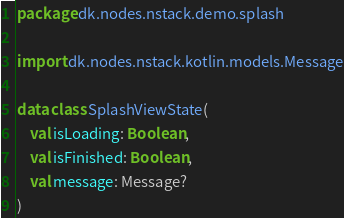Convert code to text. <code><loc_0><loc_0><loc_500><loc_500><_Kotlin_>package dk.nodes.nstack.demo.splash

import dk.nodes.nstack.kotlin.models.Message

data class SplashViewState(
    val isLoading: Boolean,
    val isFinished: Boolean,
    val message: Message?
)
</code> 